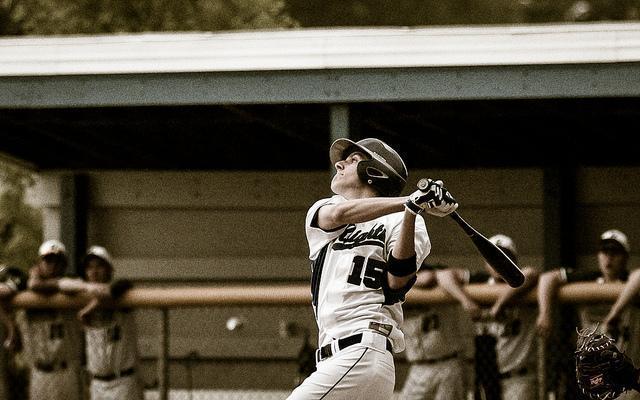How many people are there?
Give a very brief answer. 7. How many red suitcases are there in the image?
Give a very brief answer. 0. 